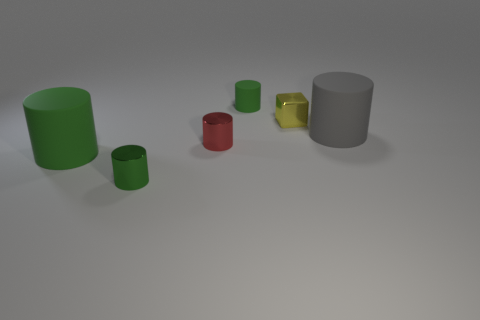Subtract all rubber cylinders. How many cylinders are left? 2 Add 3 tiny red matte cylinders. How many objects exist? 9 Subtract all cylinders. How many objects are left? 1 Subtract all gray balls. How many red cylinders are left? 1 Subtract all yellow metallic things. Subtract all matte cubes. How many objects are left? 5 Add 3 green shiny cylinders. How many green shiny cylinders are left? 4 Add 4 big purple matte cubes. How many big purple matte cubes exist? 4 Subtract all gray cylinders. How many cylinders are left? 4 Subtract 0 brown balls. How many objects are left? 6 Subtract 3 cylinders. How many cylinders are left? 2 